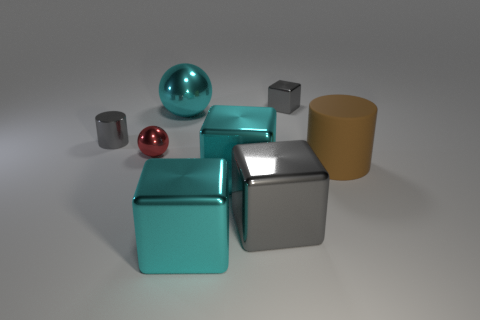What is the color of the metal thing that is right of the big shiny ball and behind the red shiny ball?
Provide a succinct answer. Gray. What number of other objects are there of the same material as the big sphere?
Provide a short and direct response. 6. Are there fewer metallic balls than big cyan balls?
Ensure brevity in your answer.  No. Do the large gray block and the big object that is behind the small red ball have the same material?
Your answer should be compact. Yes. What is the shape of the gray shiny thing on the left side of the red sphere?
Keep it short and to the point. Cylinder. Is there any other thing that has the same color as the small sphere?
Your answer should be compact. No. Are there fewer matte objects that are left of the large cyan metallic ball than cyan metal blocks?
Offer a terse response. Yes. What number of gray cylinders have the same size as the red thing?
Give a very brief answer. 1. What shape is the tiny metal object that is the same color as the small metallic cylinder?
Make the answer very short. Cube. There is a tiny gray object on the right side of the big thing behind the small metal object left of the small sphere; what shape is it?
Your response must be concise. Cube. 